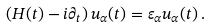<formula> <loc_0><loc_0><loc_500><loc_500>\left ( H ( t ) - i \partial _ { t } \right ) u _ { \alpha } ( t ) = \varepsilon _ { \alpha } u _ { \alpha } ( t ) \, .</formula> 